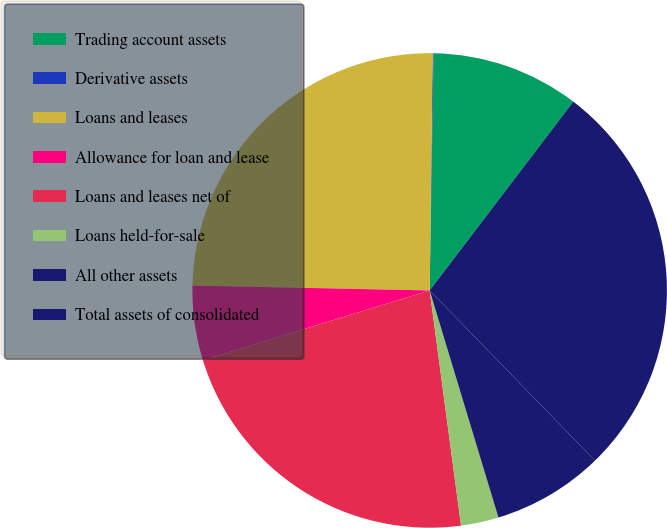Convert chart to OTSL. <chart><loc_0><loc_0><loc_500><loc_500><pie_chart><fcel>Trading account assets<fcel>Derivative assets<fcel>Loans and leases<fcel>Allowance for loan and lease<fcel>Loans and leases net of<fcel>Loans held-for-sale<fcel>All other assets<fcel>Total assets of consolidated<nl><fcel>10.09%<fcel>0.06%<fcel>24.87%<fcel>5.08%<fcel>22.36%<fcel>2.57%<fcel>7.59%<fcel>27.38%<nl></chart> 